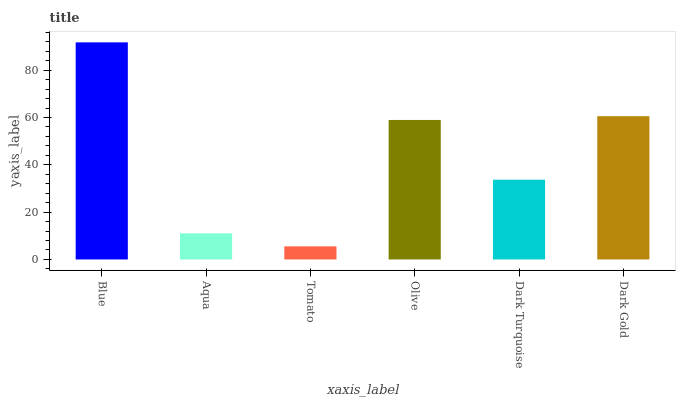Is Tomato the minimum?
Answer yes or no. Yes. Is Blue the maximum?
Answer yes or no. Yes. Is Aqua the minimum?
Answer yes or no. No. Is Aqua the maximum?
Answer yes or no. No. Is Blue greater than Aqua?
Answer yes or no. Yes. Is Aqua less than Blue?
Answer yes or no. Yes. Is Aqua greater than Blue?
Answer yes or no. No. Is Blue less than Aqua?
Answer yes or no. No. Is Olive the high median?
Answer yes or no. Yes. Is Dark Turquoise the low median?
Answer yes or no. Yes. Is Dark Turquoise the high median?
Answer yes or no. No. Is Aqua the low median?
Answer yes or no. No. 